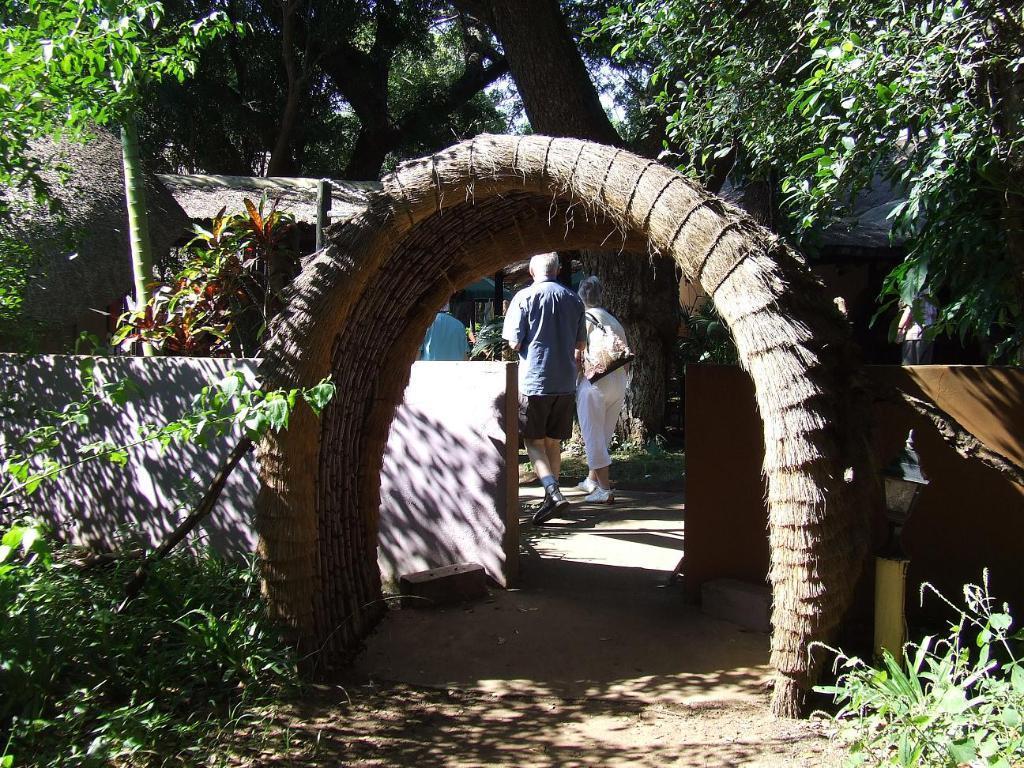Describe this image in one or two sentences. This image is taken outdoors. At the bottom of the image there is a ground with plants and grass. In the middle of the image there is an arch and a man and a woman are walking on the ground. In the background there is a wall, a hut and a few trees and plants. 